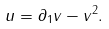<formula> <loc_0><loc_0><loc_500><loc_500>u = \partial _ { 1 } v - v ^ { 2 } .</formula> 